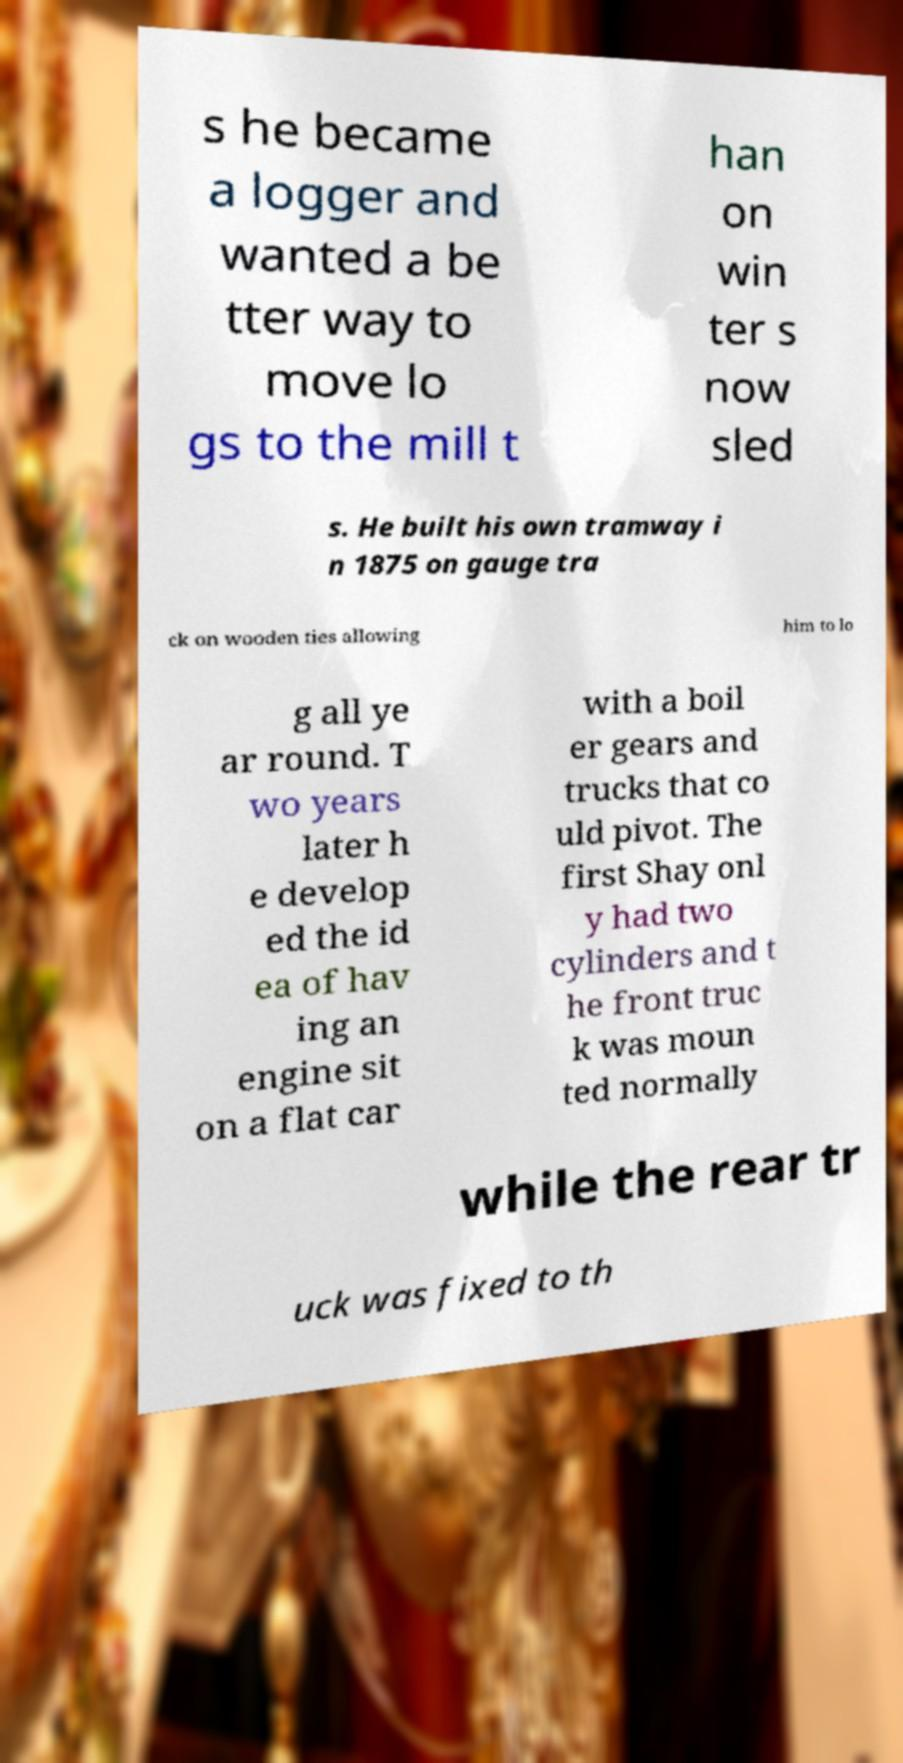I need the written content from this picture converted into text. Can you do that? s he became a logger and wanted a be tter way to move lo gs to the mill t han on win ter s now sled s. He built his own tramway i n 1875 on gauge tra ck on wooden ties allowing him to lo g all ye ar round. T wo years later h e develop ed the id ea of hav ing an engine sit on a flat car with a boil er gears and trucks that co uld pivot. The first Shay onl y had two cylinders and t he front truc k was moun ted normally while the rear tr uck was fixed to th 